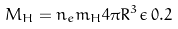Convert formula to latex. <formula><loc_0><loc_0><loc_500><loc_500>M _ { H } = n _ { e } m _ { H } 4 \pi R ^ { 3 } \epsilon \, 0 . 2</formula> 